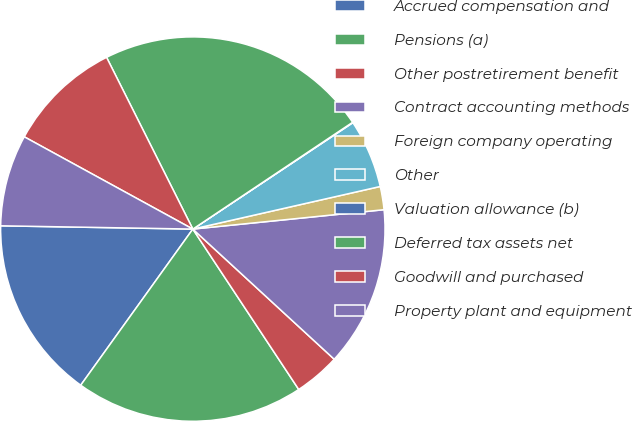<chart> <loc_0><loc_0><loc_500><loc_500><pie_chart><fcel>Accrued compensation and<fcel>Pensions (a)<fcel>Other postretirement benefit<fcel>Contract accounting methods<fcel>Foreign company operating<fcel>Other<fcel>Valuation allowance (b)<fcel>Deferred tax assets net<fcel>Goodwill and purchased<fcel>Property plant and equipment<nl><fcel>15.36%<fcel>19.2%<fcel>3.87%<fcel>13.45%<fcel>1.95%<fcel>5.78%<fcel>0.04%<fcel>23.03%<fcel>9.62%<fcel>7.7%<nl></chart> 